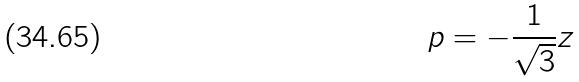<formula> <loc_0><loc_0><loc_500><loc_500>p = - \frac { 1 } { \sqrt { 3 } } z</formula> 